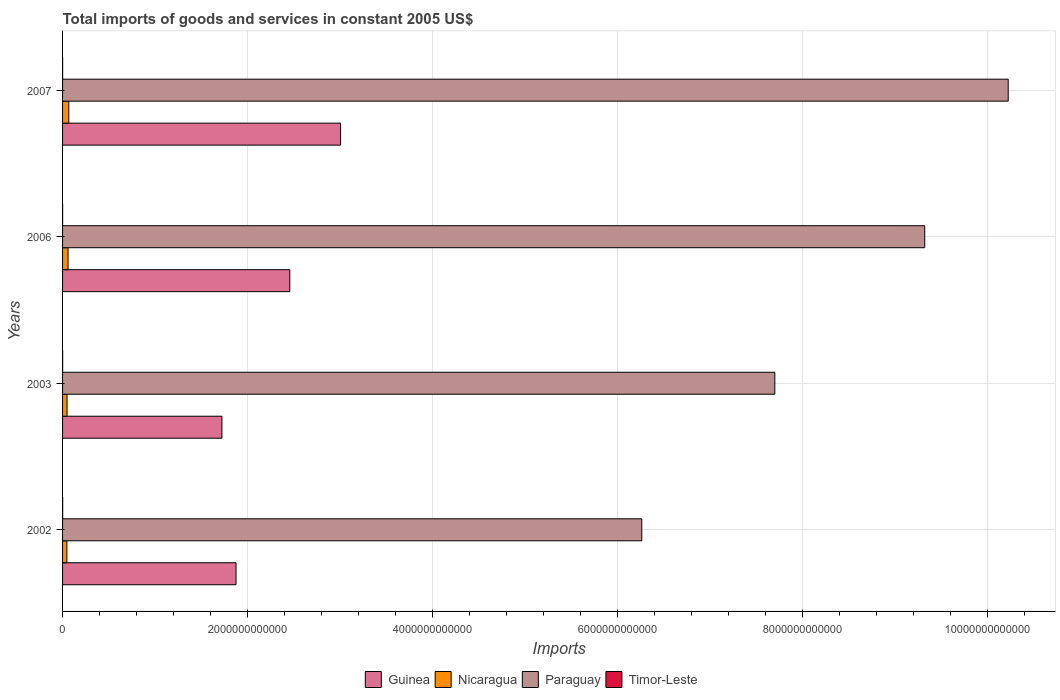Are the number of bars on each tick of the Y-axis equal?
Your response must be concise. Yes. How many bars are there on the 3rd tick from the top?
Provide a succinct answer. 4. How many bars are there on the 4th tick from the bottom?
Your answer should be compact. 4. What is the total imports of goods and services in Timor-Leste in 2007?
Your answer should be compact. 7.21e+08. Across all years, what is the maximum total imports of goods and services in Nicaragua?
Ensure brevity in your answer.  6.72e+1. Across all years, what is the minimum total imports of goods and services in Timor-Leste?
Give a very brief answer. 4.84e+08. In which year was the total imports of goods and services in Guinea maximum?
Offer a very short reply. 2007. In which year was the total imports of goods and services in Timor-Leste minimum?
Give a very brief answer. 2006. What is the total total imports of goods and services in Paraguay in the graph?
Keep it short and to the point. 3.35e+13. What is the difference between the total imports of goods and services in Guinea in 2003 and that in 2007?
Provide a succinct answer. -1.28e+12. What is the difference between the total imports of goods and services in Nicaragua in 2007 and the total imports of goods and services in Timor-Leste in 2002?
Offer a very short reply. 6.60e+1. What is the average total imports of goods and services in Timor-Leste per year?
Offer a terse response. 8.08e+08. In the year 2003, what is the difference between the total imports of goods and services in Timor-Leste and total imports of goods and services in Guinea?
Provide a succinct answer. -1.72e+12. In how many years, is the total imports of goods and services in Guinea greater than 8400000000000 US$?
Make the answer very short. 0. What is the ratio of the total imports of goods and services in Nicaragua in 2002 to that in 2006?
Your response must be concise. 0.79. Is the difference between the total imports of goods and services in Timor-Leste in 2002 and 2007 greater than the difference between the total imports of goods and services in Guinea in 2002 and 2007?
Offer a terse response. Yes. What is the difference between the highest and the second highest total imports of goods and services in Nicaragua?
Your response must be concise. 7.91e+09. What is the difference between the highest and the lowest total imports of goods and services in Guinea?
Your answer should be compact. 1.28e+12. What does the 3rd bar from the top in 2002 represents?
Give a very brief answer. Nicaragua. What does the 1st bar from the bottom in 2003 represents?
Keep it short and to the point. Guinea. Is it the case that in every year, the sum of the total imports of goods and services in Nicaragua and total imports of goods and services in Guinea is greater than the total imports of goods and services in Timor-Leste?
Keep it short and to the point. Yes. What is the difference between two consecutive major ticks on the X-axis?
Your answer should be compact. 2.00e+12. Does the graph contain grids?
Your answer should be very brief. Yes. Where does the legend appear in the graph?
Make the answer very short. Bottom center. How many legend labels are there?
Your answer should be very brief. 4. How are the legend labels stacked?
Your response must be concise. Horizontal. What is the title of the graph?
Keep it short and to the point. Total imports of goods and services in constant 2005 US$. Does "Vietnam" appear as one of the legend labels in the graph?
Keep it short and to the point. No. What is the label or title of the X-axis?
Provide a succinct answer. Imports. What is the Imports of Guinea in 2002?
Ensure brevity in your answer.  1.88e+12. What is the Imports in Nicaragua in 2002?
Provide a succinct answer. 4.67e+1. What is the Imports of Paraguay in 2002?
Provide a short and direct response. 6.26e+12. What is the Imports of Timor-Leste in 2002?
Your answer should be very brief. 1.19e+09. What is the Imports in Guinea in 2003?
Offer a very short reply. 1.72e+12. What is the Imports in Nicaragua in 2003?
Make the answer very short. 4.83e+1. What is the Imports of Paraguay in 2003?
Provide a short and direct response. 7.70e+12. What is the Imports of Timor-Leste in 2003?
Give a very brief answer. 8.43e+08. What is the Imports of Guinea in 2006?
Make the answer very short. 2.46e+12. What is the Imports in Nicaragua in 2006?
Give a very brief answer. 5.93e+1. What is the Imports in Paraguay in 2006?
Offer a very short reply. 9.32e+12. What is the Imports of Timor-Leste in 2006?
Provide a succinct answer. 4.84e+08. What is the Imports of Guinea in 2007?
Ensure brevity in your answer.  3.01e+12. What is the Imports in Nicaragua in 2007?
Your answer should be compact. 6.72e+1. What is the Imports in Paraguay in 2007?
Your response must be concise. 1.02e+13. What is the Imports of Timor-Leste in 2007?
Your answer should be compact. 7.21e+08. Across all years, what is the maximum Imports of Guinea?
Give a very brief answer. 3.01e+12. Across all years, what is the maximum Imports in Nicaragua?
Offer a very short reply. 6.72e+1. Across all years, what is the maximum Imports in Paraguay?
Your answer should be very brief. 1.02e+13. Across all years, what is the maximum Imports of Timor-Leste?
Your answer should be very brief. 1.19e+09. Across all years, what is the minimum Imports in Guinea?
Your response must be concise. 1.72e+12. Across all years, what is the minimum Imports in Nicaragua?
Your response must be concise. 4.67e+1. Across all years, what is the minimum Imports in Paraguay?
Give a very brief answer. 6.26e+12. Across all years, what is the minimum Imports in Timor-Leste?
Make the answer very short. 4.84e+08. What is the total Imports in Guinea in the graph?
Offer a very short reply. 9.06e+12. What is the total Imports in Nicaragua in the graph?
Give a very brief answer. 2.21e+11. What is the total Imports of Paraguay in the graph?
Offer a terse response. 3.35e+13. What is the total Imports in Timor-Leste in the graph?
Offer a terse response. 3.23e+09. What is the difference between the Imports in Guinea in 2002 and that in 2003?
Give a very brief answer. 1.53e+11. What is the difference between the Imports of Nicaragua in 2002 and that in 2003?
Provide a succinct answer. -1.63e+09. What is the difference between the Imports in Paraguay in 2002 and that in 2003?
Ensure brevity in your answer.  -1.44e+12. What is the difference between the Imports of Timor-Leste in 2002 and that in 2003?
Offer a terse response. 3.43e+08. What is the difference between the Imports of Guinea in 2002 and that in 2006?
Ensure brevity in your answer.  -5.81e+11. What is the difference between the Imports in Nicaragua in 2002 and that in 2006?
Offer a very short reply. -1.26e+1. What is the difference between the Imports of Paraguay in 2002 and that in 2006?
Provide a succinct answer. -3.06e+12. What is the difference between the Imports of Timor-Leste in 2002 and that in 2006?
Give a very brief answer. 7.02e+08. What is the difference between the Imports of Guinea in 2002 and that in 2007?
Keep it short and to the point. -1.13e+12. What is the difference between the Imports of Nicaragua in 2002 and that in 2007?
Make the answer very short. -2.05e+1. What is the difference between the Imports in Paraguay in 2002 and that in 2007?
Provide a succinct answer. -3.96e+12. What is the difference between the Imports of Timor-Leste in 2002 and that in 2007?
Offer a terse response. 4.65e+08. What is the difference between the Imports in Guinea in 2003 and that in 2006?
Ensure brevity in your answer.  -7.34e+11. What is the difference between the Imports in Nicaragua in 2003 and that in 2006?
Provide a short and direct response. -1.10e+1. What is the difference between the Imports in Paraguay in 2003 and that in 2006?
Keep it short and to the point. -1.62e+12. What is the difference between the Imports of Timor-Leste in 2003 and that in 2006?
Make the answer very short. 3.59e+08. What is the difference between the Imports in Guinea in 2003 and that in 2007?
Your response must be concise. -1.28e+12. What is the difference between the Imports of Nicaragua in 2003 and that in 2007?
Give a very brief answer. -1.89e+1. What is the difference between the Imports in Paraguay in 2003 and that in 2007?
Your response must be concise. -2.52e+12. What is the difference between the Imports in Timor-Leste in 2003 and that in 2007?
Provide a succinct answer. 1.22e+08. What is the difference between the Imports of Guinea in 2006 and that in 2007?
Your response must be concise. -5.49e+11. What is the difference between the Imports in Nicaragua in 2006 and that in 2007?
Your answer should be compact. -7.91e+09. What is the difference between the Imports in Paraguay in 2006 and that in 2007?
Make the answer very short. -9.03e+11. What is the difference between the Imports of Timor-Leste in 2006 and that in 2007?
Offer a very short reply. -2.37e+08. What is the difference between the Imports of Guinea in 2002 and the Imports of Nicaragua in 2003?
Your answer should be compact. 1.83e+12. What is the difference between the Imports of Guinea in 2002 and the Imports of Paraguay in 2003?
Your answer should be very brief. -5.83e+12. What is the difference between the Imports of Guinea in 2002 and the Imports of Timor-Leste in 2003?
Make the answer very short. 1.87e+12. What is the difference between the Imports of Nicaragua in 2002 and the Imports of Paraguay in 2003?
Your response must be concise. -7.65e+12. What is the difference between the Imports in Nicaragua in 2002 and the Imports in Timor-Leste in 2003?
Give a very brief answer. 4.58e+1. What is the difference between the Imports in Paraguay in 2002 and the Imports in Timor-Leste in 2003?
Provide a succinct answer. 6.26e+12. What is the difference between the Imports of Guinea in 2002 and the Imports of Nicaragua in 2006?
Provide a succinct answer. 1.82e+12. What is the difference between the Imports in Guinea in 2002 and the Imports in Paraguay in 2006?
Ensure brevity in your answer.  -7.45e+12. What is the difference between the Imports in Guinea in 2002 and the Imports in Timor-Leste in 2006?
Ensure brevity in your answer.  1.88e+12. What is the difference between the Imports of Nicaragua in 2002 and the Imports of Paraguay in 2006?
Provide a short and direct response. -9.27e+12. What is the difference between the Imports of Nicaragua in 2002 and the Imports of Timor-Leste in 2006?
Ensure brevity in your answer.  4.62e+1. What is the difference between the Imports of Paraguay in 2002 and the Imports of Timor-Leste in 2006?
Keep it short and to the point. 6.26e+12. What is the difference between the Imports in Guinea in 2002 and the Imports in Nicaragua in 2007?
Offer a terse response. 1.81e+12. What is the difference between the Imports in Guinea in 2002 and the Imports in Paraguay in 2007?
Provide a short and direct response. -8.35e+12. What is the difference between the Imports in Guinea in 2002 and the Imports in Timor-Leste in 2007?
Offer a terse response. 1.87e+12. What is the difference between the Imports of Nicaragua in 2002 and the Imports of Paraguay in 2007?
Provide a succinct answer. -1.02e+13. What is the difference between the Imports in Nicaragua in 2002 and the Imports in Timor-Leste in 2007?
Give a very brief answer. 4.60e+1. What is the difference between the Imports of Paraguay in 2002 and the Imports of Timor-Leste in 2007?
Your answer should be compact. 6.26e+12. What is the difference between the Imports of Guinea in 2003 and the Imports of Nicaragua in 2006?
Provide a succinct answer. 1.66e+12. What is the difference between the Imports of Guinea in 2003 and the Imports of Paraguay in 2006?
Your answer should be very brief. -7.60e+12. What is the difference between the Imports in Guinea in 2003 and the Imports in Timor-Leste in 2006?
Make the answer very short. 1.72e+12. What is the difference between the Imports of Nicaragua in 2003 and the Imports of Paraguay in 2006?
Provide a succinct answer. -9.27e+12. What is the difference between the Imports in Nicaragua in 2003 and the Imports in Timor-Leste in 2006?
Provide a short and direct response. 4.78e+1. What is the difference between the Imports in Paraguay in 2003 and the Imports in Timor-Leste in 2006?
Give a very brief answer. 7.70e+12. What is the difference between the Imports of Guinea in 2003 and the Imports of Nicaragua in 2007?
Keep it short and to the point. 1.66e+12. What is the difference between the Imports in Guinea in 2003 and the Imports in Paraguay in 2007?
Your response must be concise. -8.50e+12. What is the difference between the Imports in Guinea in 2003 and the Imports in Timor-Leste in 2007?
Offer a very short reply. 1.72e+12. What is the difference between the Imports of Nicaragua in 2003 and the Imports of Paraguay in 2007?
Provide a succinct answer. -1.02e+13. What is the difference between the Imports in Nicaragua in 2003 and the Imports in Timor-Leste in 2007?
Provide a succinct answer. 4.76e+1. What is the difference between the Imports in Paraguay in 2003 and the Imports in Timor-Leste in 2007?
Ensure brevity in your answer.  7.70e+12. What is the difference between the Imports of Guinea in 2006 and the Imports of Nicaragua in 2007?
Keep it short and to the point. 2.39e+12. What is the difference between the Imports in Guinea in 2006 and the Imports in Paraguay in 2007?
Provide a short and direct response. -7.77e+12. What is the difference between the Imports of Guinea in 2006 and the Imports of Timor-Leste in 2007?
Your answer should be very brief. 2.46e+12. What is the difference between the Imports of Nicaragua in 2006 and the Imports of Paraguay in 2007?
Your response must be concise. -1.02e+13. What is the difference between the Imports of Nicaragua in 2006 and the Imports of Timor-Leste in 2007?
Your response must be concise. 5.86e+1. What is the difference between the Imports of Paraguay in 2006 and the Imports of Timor-Leste in 2007?
Your answer should be very brief. 9.32e+12. What is the average Imports in Guinea per year?
Provide a short and direct response. 2.27e+12. What is the average Imports of Nicaragua per year?
Keep it short and to the point. 5.54e+1. What is the average Imports of Paraguay per year?
Provide a succinct answer. 8.38e+12. What is the average Imports of Timor-Leste per year?
Offer a very short reply. 8.08e+08. In the year 2002, what is the difference between the Imports in Guinea and Imports in Nicaragua?
Your answer should be compact. 1.83e+12. In the year 2002, what is the difference between the Imports of Guinea and Imports of Paraguay?
Give a very brief answer. -4.39e+12. In the year 2002, what is the difference between the Imports of Guinea and Imports of Timor-Leste?
Your response must be concise. 1.87e+12. In the year 2002, what is the difference between the Imports in Nicaragua and Imports in Paraguay?
Your response must be concise. -6.22e+12. In the year 2002, what is the difference between the Imports in Nicaragua and Imports in Timor-Leste?
Offer a very short reply. 4.55e+1. In the year 2002, what is the difference between the Imports of Paraguay and Imports of Timor-Leste?
Your answer should be very brief. 6.26e+12. In the year 2003, what is the difference between the Imports in Guinea and Imports in Nicaragua?
Offer a terse response. 1.67e+12. In the year 2003, what is the difference between the Imports in Guinea and Imports in Paraguay?
Give a very brief answer. -5.98e+12. In the year 2003, what is the difference between the Imports in Guinea and Imports in Timor-Leste?
Give a very brief answer. 1.72e+12. In the year 2003, what is the difference between the Imports in Nicaragua and Imports in Paraguay?
Ensure brevity in your answer.  -7.65e+12. In the year 2003, what is the difference between the Imports in Nicaragua and Imports in Timor-Leste?
Ensure brevity in your answer.  4.75e+1. In the year 2003, what is the difference between the Imports in Paraguay and Imports in Timor-Leste?
Offer a terse response. 7.70e+12. In the year 2006, what is the difference between the Imports of Guinea and Imports of Nicaragua?
Make the answer very short. 2.40e+12. In the year 2006, what is the difference between the Imports in Guinea and Imports in Paraguay?
Ensure brevity in your answer.  -6.86e+12. In the year 2006, what is the difference between the Imports in Guinea and Imports in Timor-Leste?
Your response must be concise. 2.46e+12. In the year 2006, what is the difference between the Imports of Nicaragua and Imports of Paraguay?
Offer a terse response. -9.26e+12. In the year 2006, what is the difference between the Imports in Nicaragua and Imports in Timor-Leste?
Offer a very short reply. 5.88e+1. In the year 2006, what is the difference between the Imports in Paraguay and Imports in Timor-Leste?
Make the answer very short. 9.32e+12. In the year 2007, what is the difference between the Imports of Guinea and Imports of Nicaragua?
Keep it short and to the point. 2.94e+12. In the year 2007, what is the difference between the Imports of Guinea and Imports of Paraguay?
Keep it short and to the point. -7.22e+12. In the year 2007, what is the difference between the Imports in Guinea and Imports in Timor-Leste?
Keep it short and to the point. 3.01e+12. In the year 2007, what is the difference between the Imports of Nicaragua and Imports of Paraguay?
Make the answer very short. -1.02e+13. In the year 2007, what is the difference between the Imports of Nicaragua and Imports of Timor-Leste?
Your answer should be very brief. 6.65e+1. In the year 2007, what is the difference between the Imports in Paraguay and Imports in Timor-Leste?
Ensure brevity in your answer.  1.02e+13. What is the ratio of the Imports in Guinea in 2002 to that in 2003?
Your answer should be compact. 1.09. What is the ratio of the Imports in Nicaragua in 2002 to that in 2003?
Provide a succinct answer. 0.97. What is the ratio of the Imports of Paraguay in 2002 to that in 2003?
Give a very brief answer. 0.81. What is the ratio of the Imports in Timor-Leste in 2002 to that in 2003?
Make the answer very short. 1.41. What is the ratio of the Imports of Guinea in 2002 to that in 2006?
Ensure brevity in your answer.  0.76. What is the ratio of the Imports of Nicaragua in 2002 to that in 2006?
Provide a short and direct response. 0.79. What is the ratio of the Imports in Paraguay in 2002 to that in 2006?
Make the answer very short. 0.67. What is the ratio of the Imports of Timor-Leste in 2002 to that in 2006?
Your answer should be compact. 2.45. What is the ratio of the Imports in Guinea in 2002 to that in 2007?
Make the answer very short. 0.62. What is the ratio of the Imports of Nicaragua in 2002 to that in 2007?
Provide a succinct answer. 0.69. What is the ratio of the Imports in Paraguay in 2002 to that in 2007?
Offer a terse response. 0.61. What is the ratio of the Imports of Timor-Leste in 2002 to that in 2007?
Ensure brevity in your answer.  1.64. What is the ratio of the Imports in Guinea in 2003 to that in 2006?
Your answer should be compact. 0.7. What is the ratio of the Imports in Nicaragua in 2003 to that in 2006?
Give a very brief answer. 0.81. What is the ratio of the Imports of Paraguay in 2003 to that in 2006?
Keep it short and to the point. 0.83. What is the ratio of the Imports of Timor-Leste in 2003 to that in 2006?
Give a very brief answer. 1.74. What is the ratio of the Imports in Guinea in 2003 to that in 2007?
Make the answer very short. 0.57. What is the ratio of the Imports of Nicaragua in 2003 to that in 2007?
Ensure brevity in your answer.  0.72. What is the ratio of the Imports in Paraguay in 2003 to that in 2007?
Keep it short and to the point. 0.75. What is the ratio of the Imports of Timor-Leste in 2003 to that in 2007?
Offer a terse response. 1.17. What is the ratio of the Imports in Guinea in 2006 to that in 2007?
Offer a very short reply. 0.82. What is the ratio of the Imports in Nicaragua in 2006 to that in 2007?
Ensure brevity in your answer.  0.88. What is the ratio of the Imports of Paraguay in 2006 to that in 2007?
Provide a succinct answer. 0.91. What is the ratio of the Imports in Timor-Leste in 2006 to that in 2007?
Your answer should be very brief. 0.67. What is the difference between the highest and the second highest Imports of Guinea?
Ensure brevity in your answer.  5.49e+11. What is the difference between the highest and the second highest Imports of Nicaragua?
Ensure brevity in your answer.  7.91e+09. What is the difference between the highest and the second highest Imports in Paraguay?
Offer a terse response. 9.03e+11. What is the difference between the highest and the second highest Imports of Timor-Leste?
Provide a succinct answer. 3.43e+08. What is the difference between the highest and the lowest Imports in Guinea?
Your response must be concise. 1.28e+12. What is the difference between the highest and the lowest Imports of Nicaragua?
Provide a succinct answer. 2.05e+1. What is the difference between the highest and the lowest Imports of Paraguay?
Offer a terse response. 3.96e+12. What is the difference between the highest and the lowest Imports in Timor-Leste?
Give a very brief answer. 7.02e+08. 